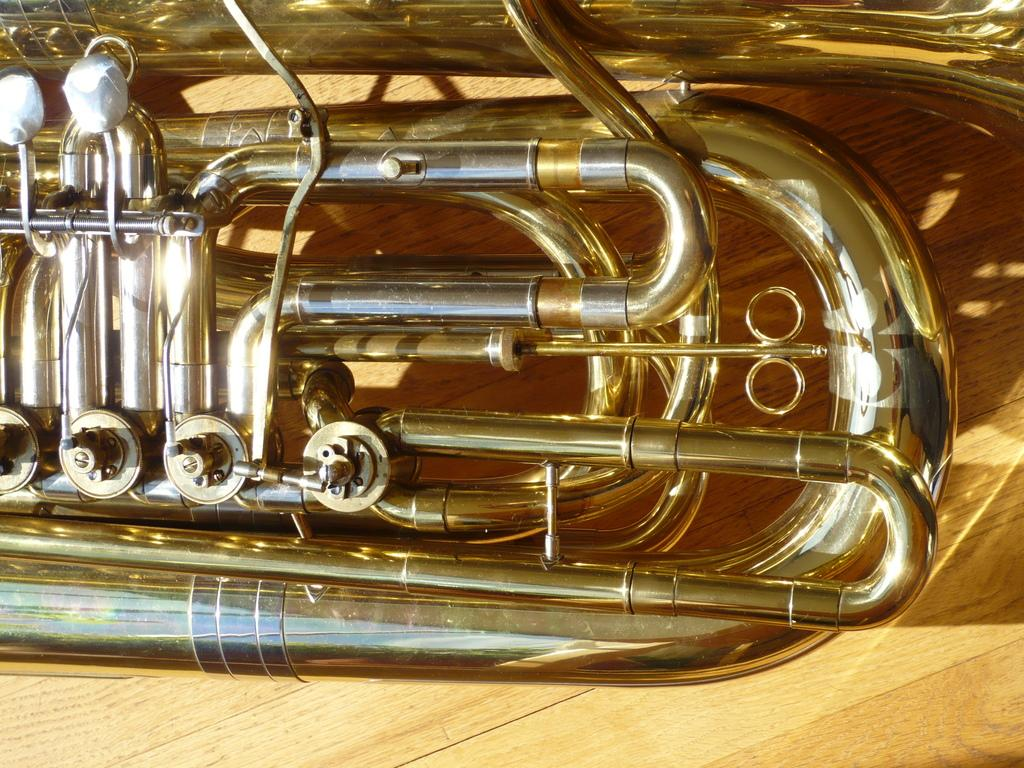What musical instrument is present in the image? There is a trumpet in the image. Where is the trumpet located? The trumpet is placed on a table. What type of caption is written on the tent in the image? There is no tent present in the image, and therefore no caption can be observed. 